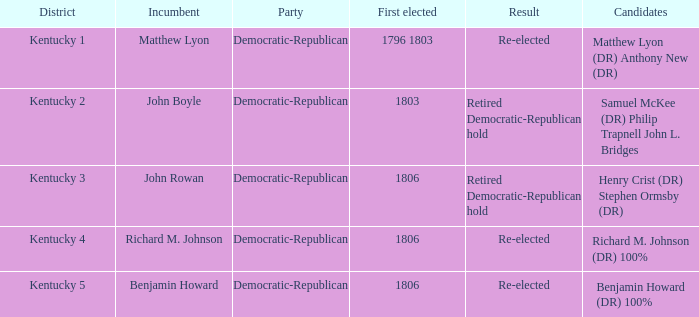Name the candidates for john boyle Samuel McKee (DR) Philip Trapnell John L. Bridges. 